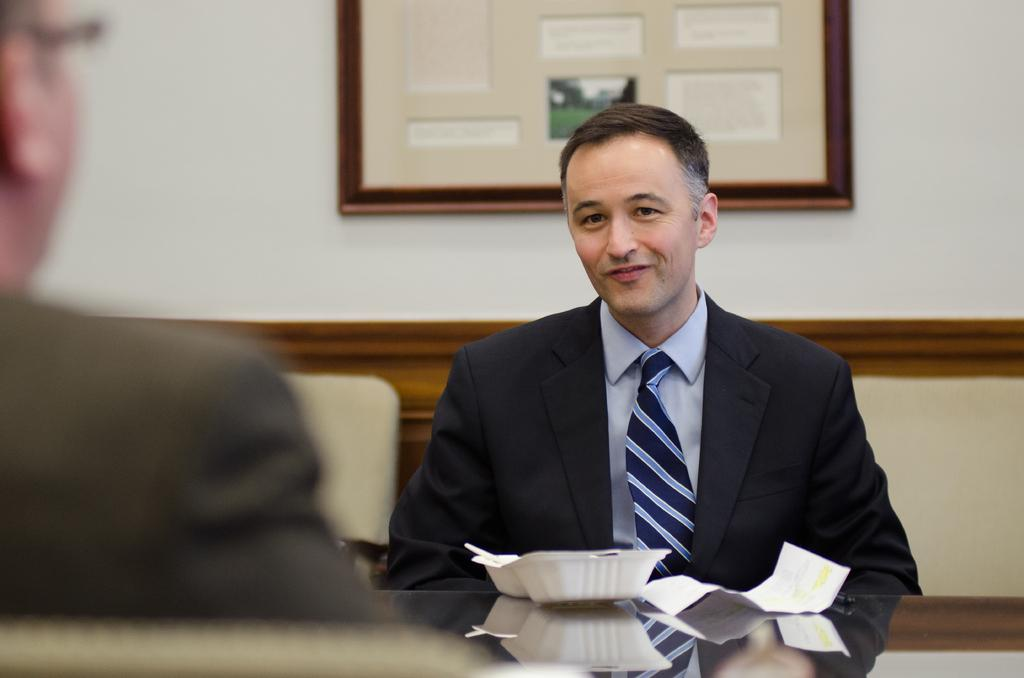How many people are present in the image? There are two persons in the image. What is on the table in the image? There is a paper, a bowl, and a spoon on the table. What is hanging on the wall in the image? There is a frame on the wall. Where are the chairs located in the image? There are chairs on both the right and left sides of the image. What type of love can be seen between the two persons in the image? There is no indication of love or any emotional connection between the two persons in the image. 